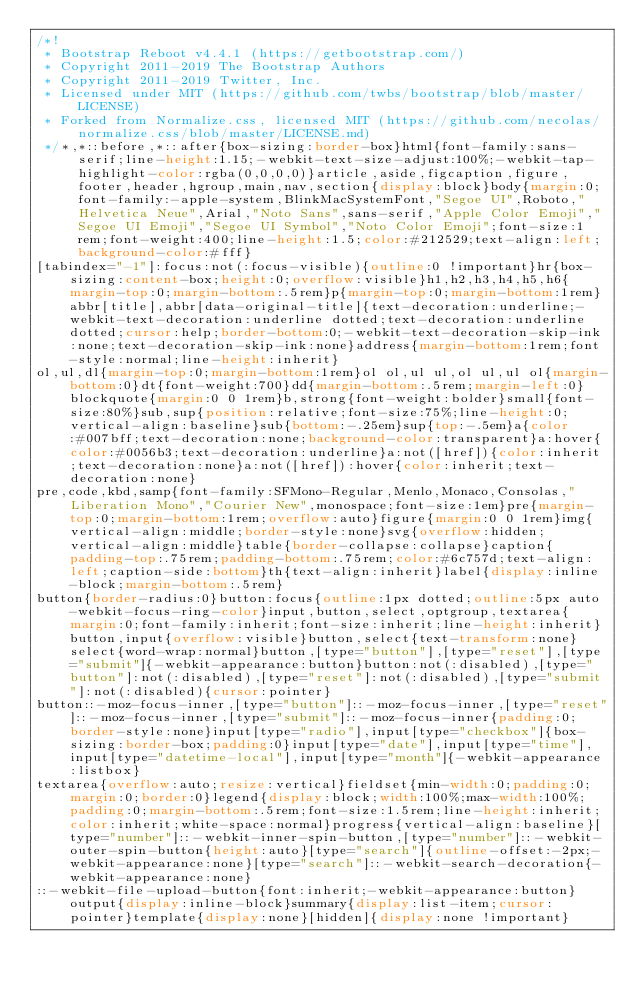Convert code to text. <code><loc_0><loc_0><loc_500><loc_500><_CSS_>/*!
 * Bootstrap Reboot v4.4.1 (https://getbootstrap.com/)
 * Copyright 2011-2019 The Bootstrap Authors
 * Copyright 2011-2019 Twitter, Inc.
 * Licensed under MIT (https://github.com/twbs/bootstrap/blob/master/LICENSE)
 * Forked from Normalize.css, licensed MIT (https://github.com/necolas/normalize.css/blob/master/LICENSE.md)
 */*,*::before,*::after{box-sizing:border-box}html{font-family:sans-serif;line-height:1.15;-webkit-text-size-adjust:100%;-webkit-tap-highlight-color:rgba(0,0,0,0)}article,aside,figcaption,figure,footer,header,hgroup,main,nav,section{display:block}body{margin:0;font-family:-apple-system,BlinkMacSystemFont,"Segoe UI",Roboto,"Helvetica Neue",Arial,"Noto Sans",sans-serif,"Apple Color Emoji","Segoe UI Emoji","Segoe UI Symbol","Noto Color Emoji";font-size:1rem;font-weight:400;line-height:1.5;color:#212529;text-align:left;background-color:#fff}
[tabindex="-1"]:focus:not(:focus-visible){outline:0 !important}hr{box-sizing:content-box;height:0;overflow:visible}h1,h2,h3,h4,h5,h6{margin-top:0;margin-bottom:.5rem}p{margin-top:0;margin-bottom:1rem}abbr[title],abbr[data-original-title]{text-decoration:underline;-webkit-text-decoration:underline dotted;text-decoration:underline dotted;cursor:help;border-bottom:0;-webkit-text-decoration-skip-ink:none;text-decoration-skip-ink:none}address{margin-bottom:1rem;font-style:normal;line-height:inherit}
ol,ul,dl{margin-top:0;margin-bottom:1rem}ol ol,ul ul,ol ul,ul ol{margin-bottom:0}dt{font-weight:700}dd{margin-bottom:.5rem;margin-left:0}blockquote{margin:0 0 1rem}b,strong{font-weight:bolder}small{font-size:80%}sub,sup{position:relative;font-size:75%;line-height:0;vertical-align:baseline}sub{bottom:-.25em}sup{top:-.5em}a{color:#007bff;text-decoration:none;background-color:transparent}a:hover{color:#0056b3;text-decoration:underline}a:not([href]){color:inherit;text-decoration:none}a:not([href]):hover{color:inherit;text-decoration:none}
pre,code,kbd,samp{font-family:SFMono-Regular,Menlo,Monaco,Consolas,"Liberation Mono","Courier New",monospace;font-size:1em}pre{margin-top:0;margin-bottom:1rem;overflow:auto}figure{margin:0 0 1rem}img{vertical-align:middle;border-style:none}svg{overflow:hidden;vertical-align:middle}table{border-collapse:collapse}caption{padding-top:.75rem;padding-bottom:.75rem;color:#6c757d;text-align:left;caption-side:bottom}th{text-align:inherit}label{display:inline-block;margin-bottom:.5rem}
button{border-radius:0}button:focus{outline:1px dotted;outline:5px auto -webkit-focus-ring-color}input,button,select,optgroup,textarea{margin:0;font-family:inherit;font-size:inherit;line-height:inherit}button,input{overflow:visible}button,select{text-transform:none}select{word-wrap:normal}button,[type="button"],[type="reset"],[type="submit"]{-webkit-appearance:button}button:not(:disabled),[type="button"]:not(:disabled),[type="reset"]:not(:disabled),[type="submit"]:not(:disabled){cursor:pointer}
button::-moz-focus-inner,[type="button"]::-moz-focus-inner,[type="reset"]::-moz-focus-inner,[type="submit"]::-moz-focus-inner{padding:0;border-style:none}input[type="radio"],input[type="checkbox"]{box-sizing:border-box;padding:0}input[type="date"],input[type="time"],input[type="datetime-local"],input[type="month"]{-webkit-appearance:listbox}
textarea{overflow:auto;resize:vertical}fieldset{min-width:0;padding:0;margin:0;border:0}legend{display:block;width:100%;max-width:100%;padding:0;margin-bottom:.5rem;font-size:1.5rem;line-height:inherit;color:inherit;white-space:normal}progress{vertical-align:baseline}[type="number"]::-webkit-inner-spin-button,[type="number"]::-webkit-outer-spin-button{height:auto}[type="search"]{outline-offset:-2px;-webkit-appearance:none}[type="search"]::-webkit-search-decoration{-webkit-appearance:none}
::-webkit-file-upload-button{font:inherit;-webkit-appearance:button}output{display:inline-block}summary{display:list-item;cursor:pointer}template{display:none}[hidden]{display:none !important}</code> 